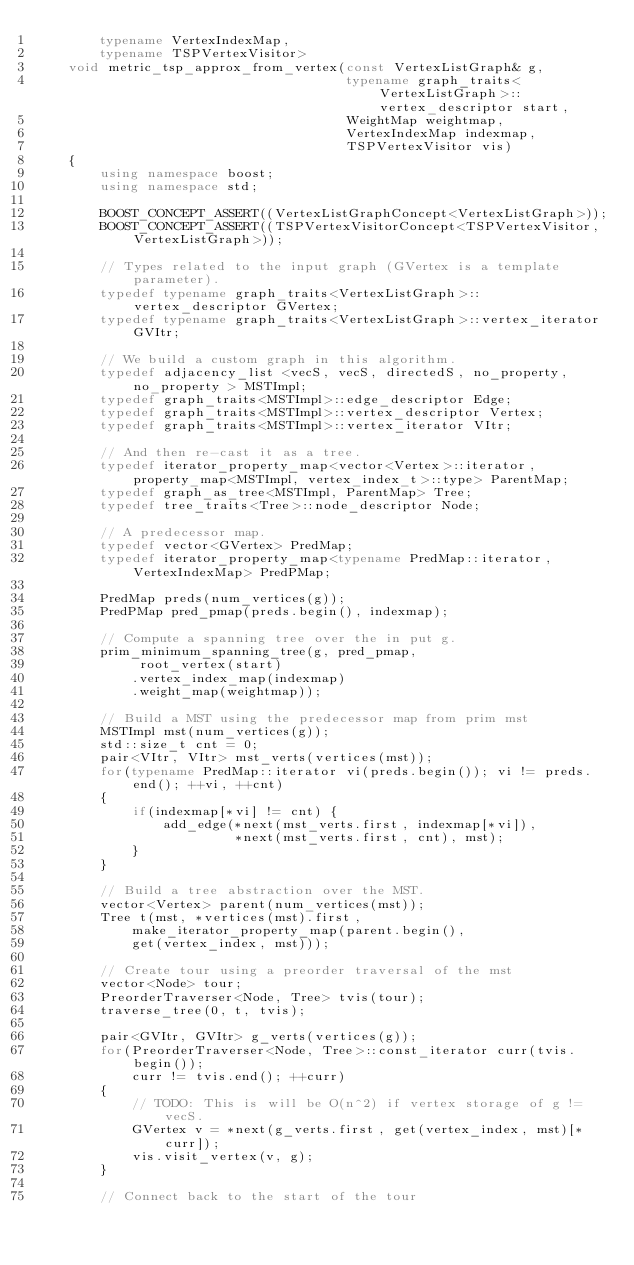Convert code to text. <code><loc_0><loc_0><loc_500><loc_500><_C++_>        typename VertexIndexMap,
        typename TSPVertexVisitor>
    void metric_tsp_approx_from_vertex(const VertexListGraph& g,
                                       typename graph_traits<VertexListGraph>::vertex_descriptor start,
                                       WeightMap weightmap,
                                       VertexIndexMap indexmap,
                                       TSPVertexVisitor vis)
    {
        using namespace boost;
        using namespace std;

        BOOST_CONCEPT_ASSERT((VertexListGraphConcept<VertexListGraph>));
        BOOST_CONCEPT_ASSERT((TSPVertexVisitorConcept<TSPVertexVisitor, VertexListGraph>));

        // Types related to the input graph (GVertex is a template parameter).
        typedef typename graph_traits<VertexListGraph>::vertex_descriptor GVertex;
        typedef typename graph_traits<VertexListGraph>::vertex_iterator GVItr;

        // We build a custom graph in this algorithm.
        typedef adjacency_list <vecS, vecS, directedS, no_property, no_property > MSTImpl;
        typedef graph_traits<MSTImpl>::edge_descriptor Edge;
        typedef graph_traits<MSTImpl>::vertex_descriptor Vertex;
        typedef graph_traits<MSTImpl>::vertex_iterator VItr;

        // And then re-cast it as a tree.
        typedef iterator_property_map<vector<Vertex>::iterator, property_map<MSTImpl, vertex_index_t>::type> ParentMap;
        typedef graph_as_tree<MSTImpl, ParentMap> Tree;
        typedef tree_traits<Tree>::node_descriptor Node;

        // A predecessor map.
        typedef vector<GVertex> PredMap;
        typedef iterator_property_map<typename PredMap::iterator, VertexIndexMap> PredPMap;

        PredMap preds(num_vertices(g));
        PredPMap pred_pmap(preds.begin(), indexmap);

        // Compute a spanning tree over the in put g.
        prim_minimum_spanning_tree(g, pred_pmap,
             root_vertex(start)
            .vertex_index_map(indexmap)
            .weight_map(weightmap));

        // Build a MST using the predecessor map from prim mst
        MSTImpl mst(num_vertices(g));
        std::size_t cnt = 0;
        pair<VItr, VItr> mst_verts(vertices(mst));
        for(typename PredMap::iterator vi(preds.begin()); vi != preds.end(); ++vi, ++cnt)
        {
            if(indexmap[*vi] != cnt) {
                add_edge(*next(mst_verts.first, indexmap[*vi]),
                         *next(mst_verts.first, cnt), mst);
            }
        }

        // Build a tree abstraction over the MST.
        vector<Vertex> parent(num_vertices(mst));
        Tree t(mst, *vertices(mst).first,
            make_iterator_property_map(parent.begin(),
            get(vertex_index, mst)));

        // Create tour using a preorder traversal of the mst
        vector<Node> tour;
        PreorderTraverser<Node, Tree> tvis(tour);
        traverse_tree(0, t, tvis);

        pair<GVItr, GVItr> g_verts(vertices(g));
        for(PreorderTraverser<Node, Tree>::const_iterator curr(tvis.begin());
            curr != tvis.end(); ++curr)
        {
            // TODO: This is will be O(n^2) if vertex storage of g != vecS.
            GVertex v = *next(g_verts.first, get(vertex_index, mst)[*curr]);
            vis.visit_vertex(v, g);
        }

        // Connect back to the start of the tour</code> 